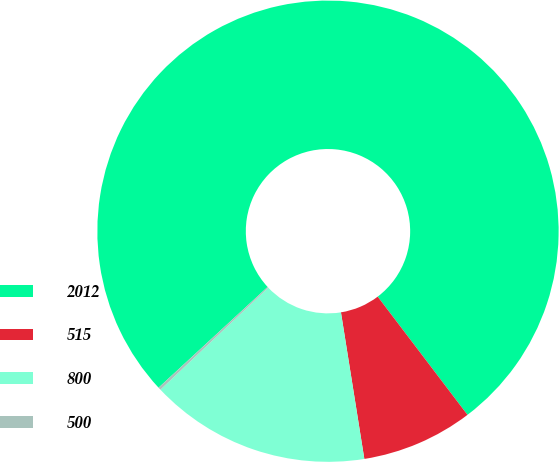Convert chart. <chart><loc_0><loc_0><loc_500><loc_500><pie_chart><fcel>2012<fcel>515<fcel>800<fcel>500<nl><fcel>76.53%<fcel>7.82%<fcel>15.46%<fcel>0.19%<nl></chart> 